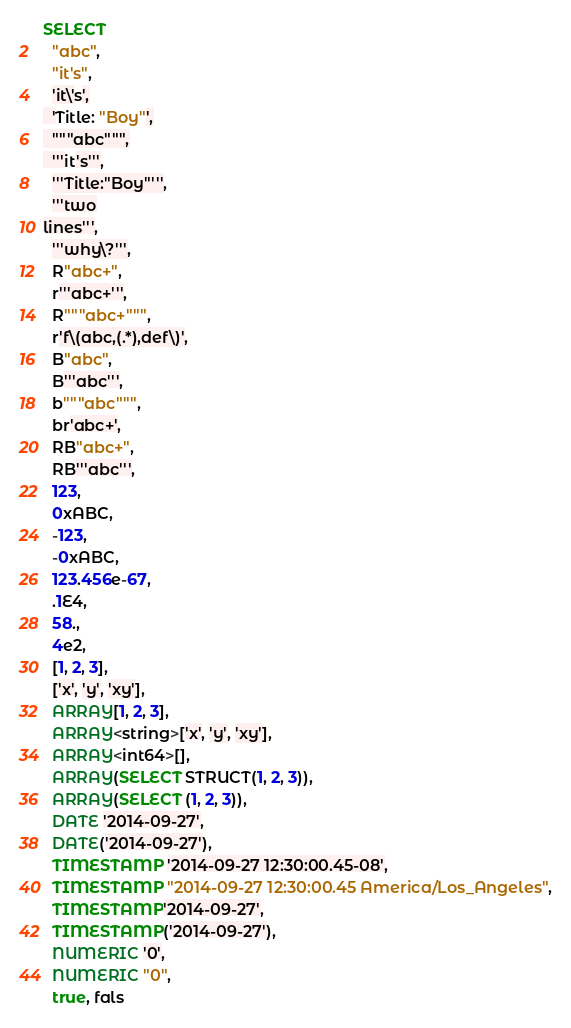Convert code to text. <code><loc_0><loc_0><loc_500><loc_500><_SQL_>SELECT
  "abc",
  "it's",
  'it\'s',
  'Title: "Boy"',
  """abc""",
  '''it's''',
  '''Title:"Boy"''',
  '''two
lines''',
  '''why\?''',
  R"abc+",
  r'''abc+''',
  R"""abc+""",
  r'f\(abc,(.*),def\)',
  B"abc",
  B'''abc''',
  b"""abc""",
  br'abc+',
  RB"abc+",
  RB'''abc''',
  123,
  0xABC,
  -123,
  -0xABC,
  123.456e-67,
  .1E4,
  58.,
  4e2,
  [1, 2, 3],
  ['x', 'y', 'xy'],
  ARRAY[1, 2, 3],
  ARRAY<string>['x', 'y', 'xy'],
  ARRAY<int64>[],
  ARRAY(SELECT STRUCT(1, 2, 3)),
  ARRAY(SELECT (1, 2, 3)),
  DATE '2014-09-27',
  DATE('2014-09-27'),
  TIMESTAMP '2014-09-27 12:30:00.45-08',
  TIMESTAMP "2014-09-27 12:30:00.45 America/Los_Angeles",
  TIMESTAMP'2014-09-27',
  TIMESTAMP('2014-09-27'),
  NUMERIC '0',
  NUMERIC "0",
  true, fals</code> 